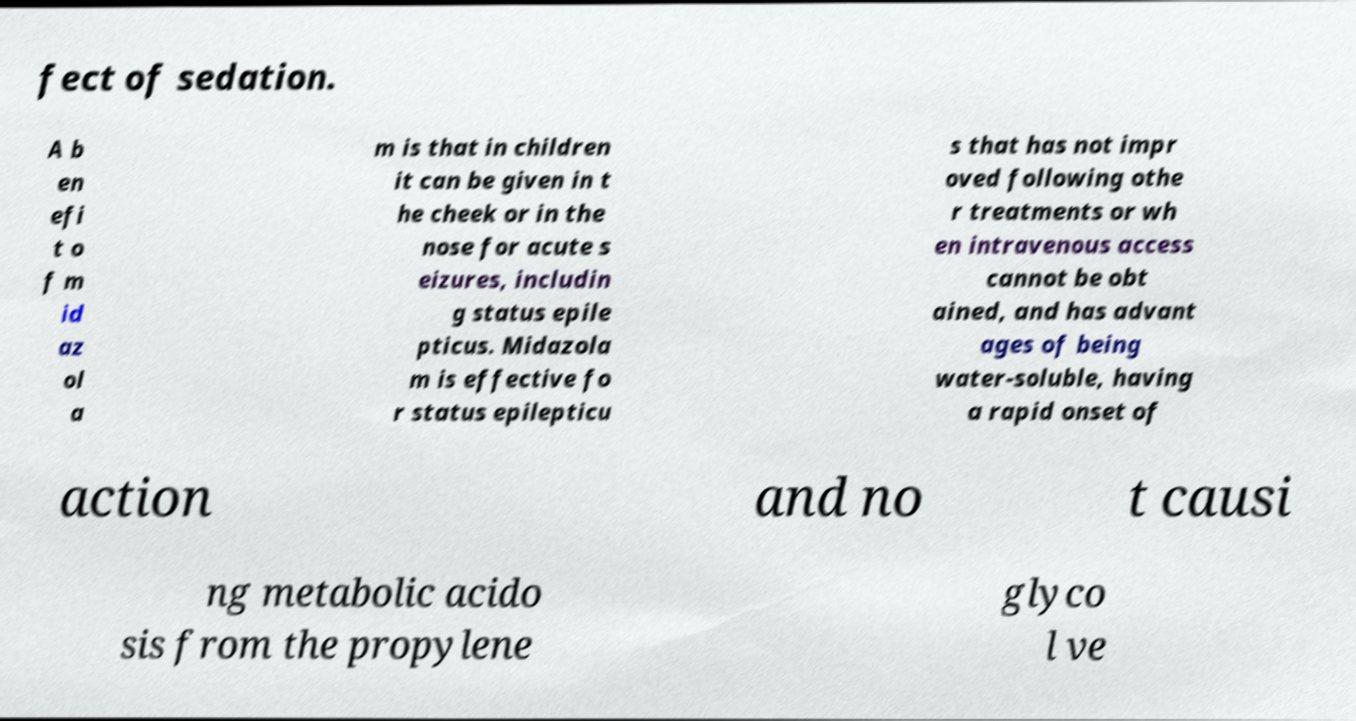Could you extract and type out the text from this image? fect of sedation. A b en efi t o f m id az ol a m is that in children it can be given in t he cheek or in the nose for acute s eizures, includin g status epile pticus. Midazola m is effective fo r status epilepticu s that has not impr oved following othe r treatments or wh en intravenous access cannot be obt ained, and has advant ages of being water-soluble, having a rapid onset of action and no t causi ng metabolic acido sis from the propylene glyco l ve 